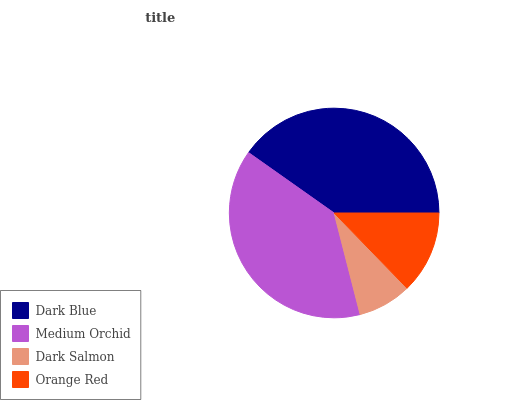Is Dark Salmon the minimum?
Answer yes or no. Yes. Is Dark Blue the maximum?
Answer yes or no. Yes. Is Medium Orchid the minimum?
Answer yes or no. No. Is Medium Orchid the maximum?
Answer yes or no. No. Is Dark Blue greater than Medium Orchid?
Answer yes or no. Yes. Is Medium Orchid less than Dark Blue?
Answer yes or no. Yes. Is Medium Orchid greater than Dark Blue?
Answer yes or no. No. Is Dark Blue less than Medium Orchid?
Answer yes or no. No. Is Medium Orchid the high median?
Answer yes or no. Yes. Is Orange Red the low median?
Answer yes or no. Yes. Is Orange Red the high median?
Answer yes or no. No. Is Medium Orchid the low median?
Answer yes or no. No. 